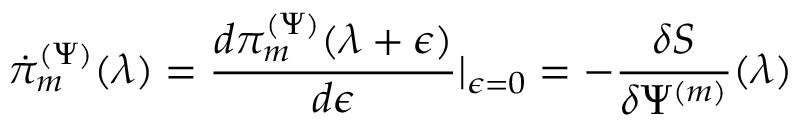Convert formula to latex. <formula><loc_0><loc_0><loc_500><loc_500>\dot { \pi } _ { m } ^ { ( \Psi ) } ( \lambda ) = \frac { d \pi _ { m } ^ { ( \Psi ) } ( \lambda + \epsilon ) } { d \epsilon } | _ { \epsilon = 0 } = - \frac { \delta S } { \delta \Psi ^ { ( m ) } } ( \lambda )</formula> 